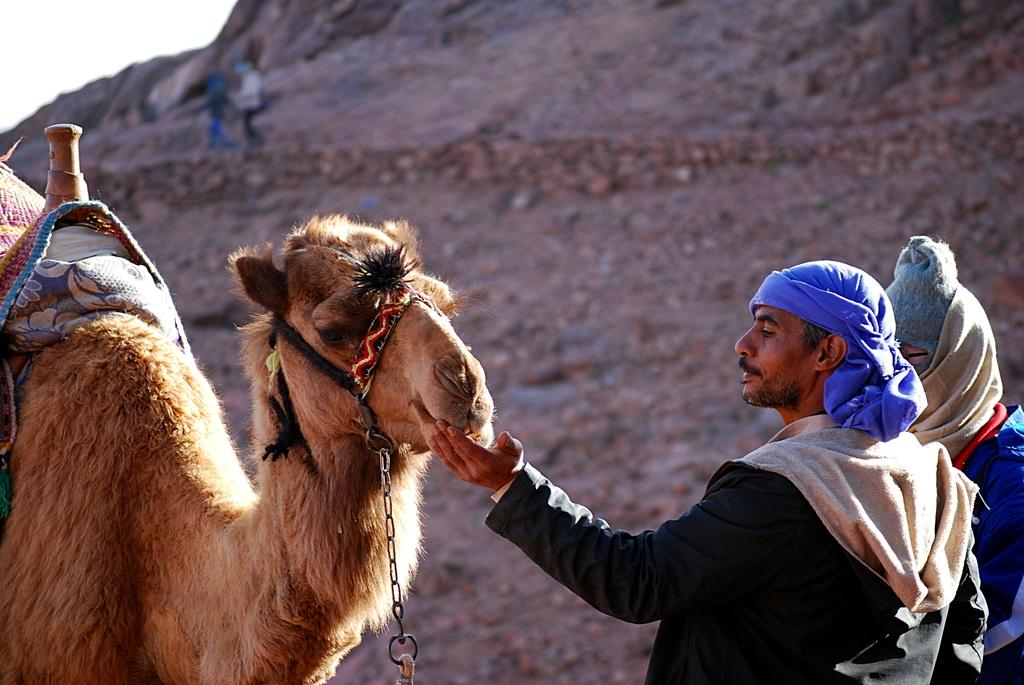What animal is present in the image? There is a camel in the image. Who is standing in front of the camel? There are two people standing in front of the camel. What activity is happening in the background of the image? In the background of the image, there are two people walking on the surface of a rock. What type of jelly can be seen in the image? There is no jelly present in the image. 